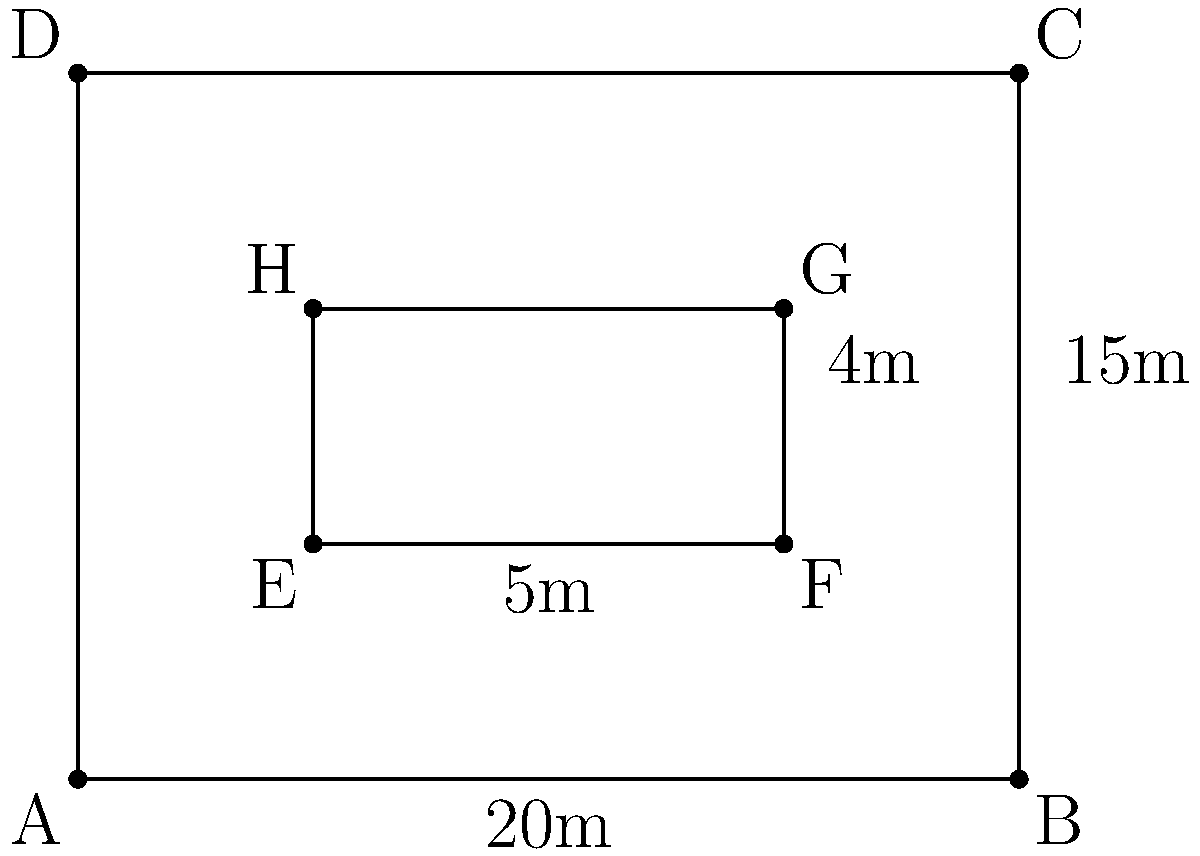As a landlord, you're ensuring compliance with occupancy regulations for your apartment building. The building has a rectangular shape with dimensions 20m by 15m, and contains a single rectangular apartment with dimensions 5m by 4m. What is the total floor area of the building that can be used for occupancy, excluding the apartment? Let's approach this step-by-step:

1) First, calculate the total area of the building:
   $A_{total} = 20\text{m} \times 15\text{m} = 300\text{m}^2$

2) Next, calculate the area of the apartment:
   $A_{apartment} = 5\text{m} \times 4\text{m} = 20\text{m}^2$

3) The area that can be used for occupancy is the difference between the total area and the apartment area:
   $A_{occupancy} = A_{total} - A_{apartment}$
   $A_{occupancy} = 300\text{m}^2 - 20\text{m}^2 = 280\text{m}^2$

Therefore, the total floor area that can be used for occupancy, excluding the apartment, is 280 square meters.
Answer: $280\text{m}^2$ 